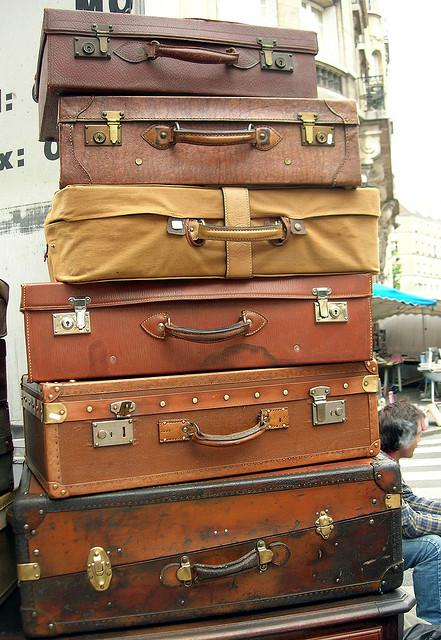What is the building at the back? Please explain your reasoning. hotel. There are luggage stacked in front of the building. 